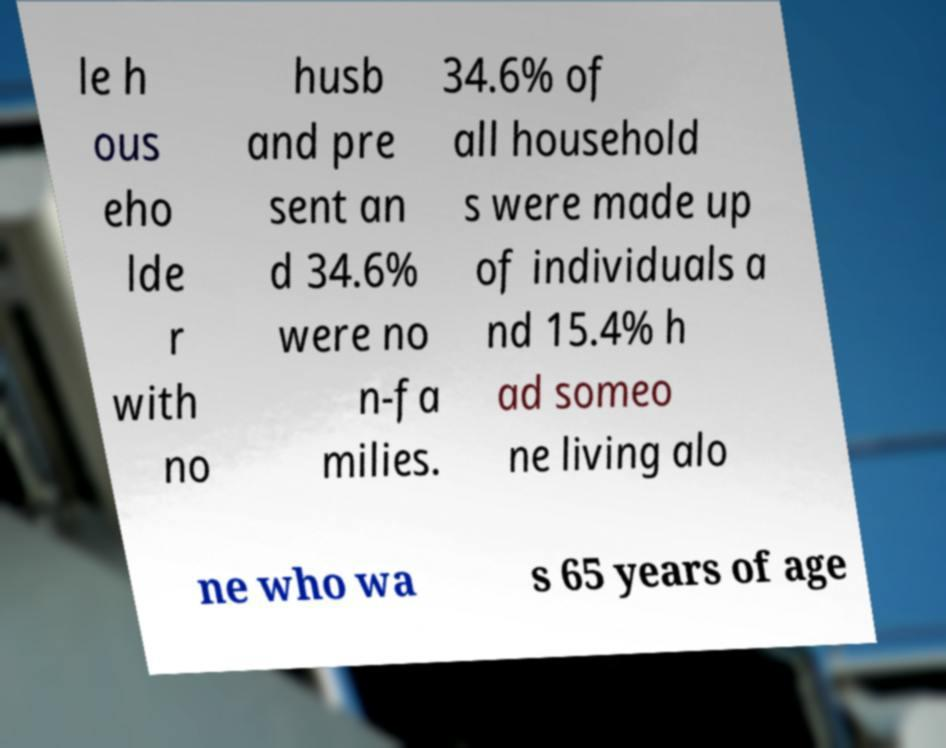Suppose this document was part of a larger presentation, what other information might you expect to find in it? If part of a larger presentation, this document might include a broader range of demographic statistics, such as the distribution of age groups within the population, marital status, employment figures, or housing conditions. It might also feature analyses, trends over time, and perhaps comparisons to previous years or different regions, providing a comprehensive view of the subject matter. 